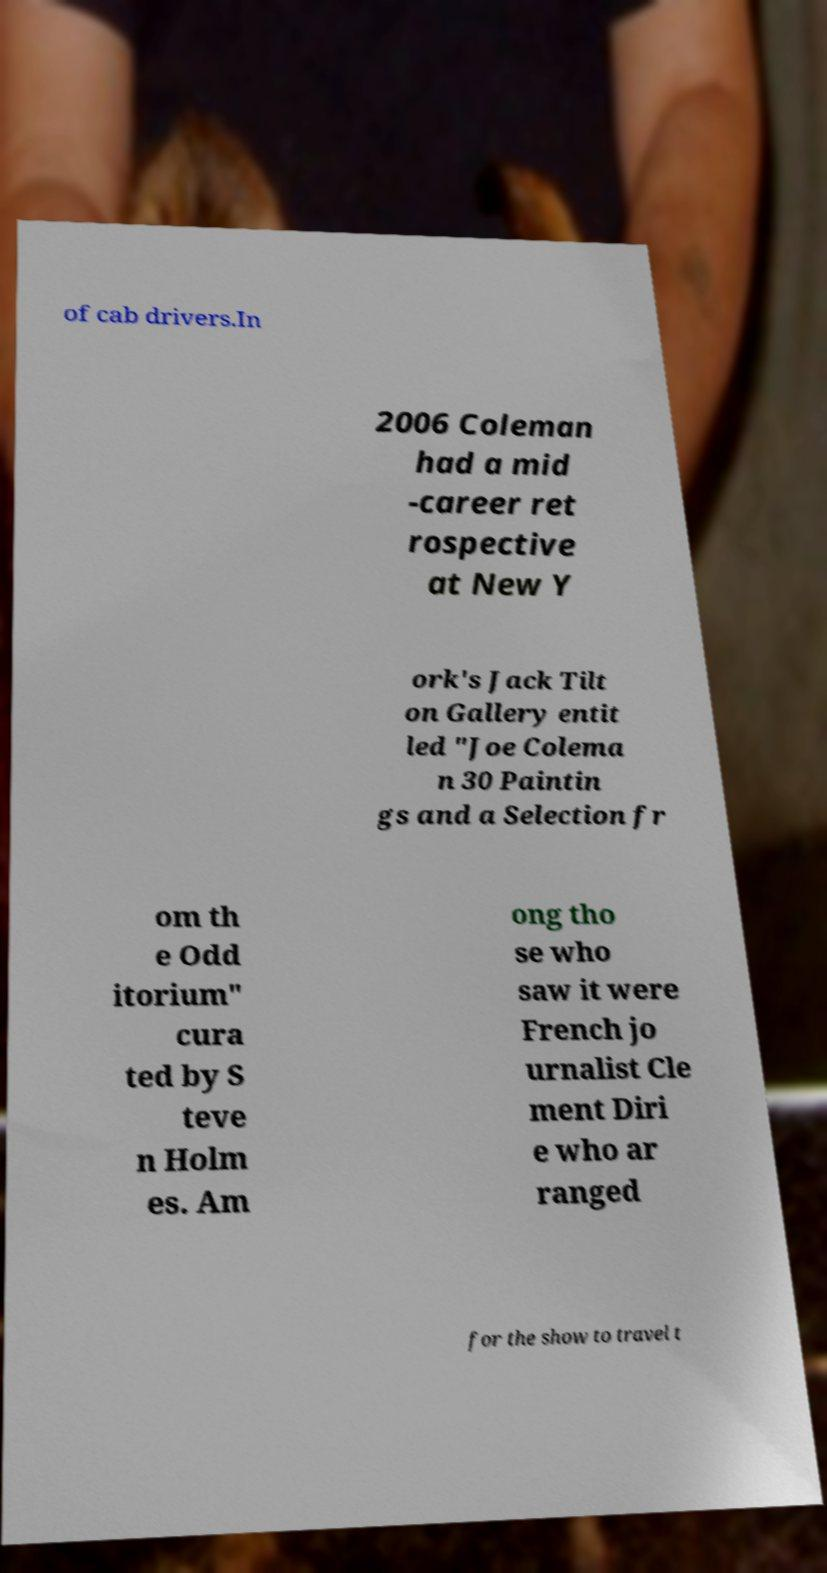Please identify and transcribe the text found in this image. of cab drivers.In 2006 Coleman had a mid -career ret rospective at New Y ork's Jack Tilt on Gallery entit led "Joe Colema n 30 Paintin gs and a Selection fr om th e Odd itorium" cura ted by S teve n Holm es. Am ong tho se who saw it were French jo urnalist Cle ment Diri e who ar ranged for the show to travel t 